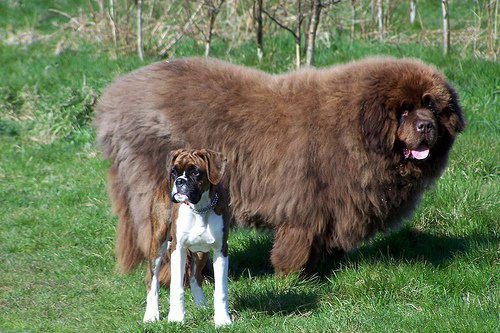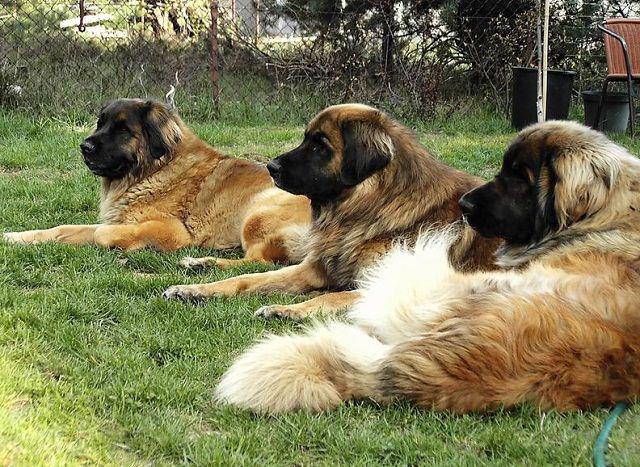The first image is the image on the left, the second image is the image on the right. Given the left and right images, does the statement "One image includes a dog standing in profile, and the other image contains at least two dogs." hold true? Answer yes or no. Yes. The first image is the image on the left, the second image is the image on the right. For the images shown, is this caption "There are exactly two dogs in the left image." true? Answer yes or no. Yes. 